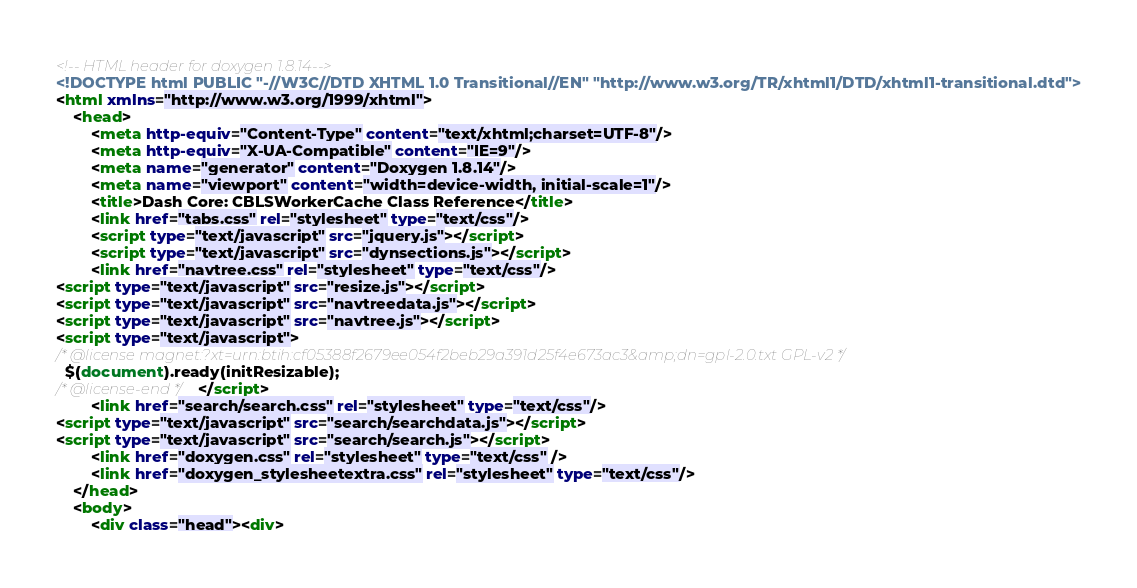<code> <loc_0><loc_0><loc_500><loc_500><_HTML_><!-- HTML header for doxygen 1.8.14-->
<!DOCTYPE html PUBLIC "-//W3C//DTD XHTML 1.0 Transitional//EN" "http://www.w3.org/TR/xhtml1/DTD/xhtml1-transitional.dtd">
<html xmlns="http://www.w3.org/1999/xhtml">
	<head>
		<meta http-equiv="Content-Type" content="text/xhtml;charset=UTF-8"/>
		<meta http-equiv="X-UA-Compatible" content="IE=9"/>
		<meta name="generator" content="Doxygen 1.8.14"/>
		<meta name="viewport" content="width=device-width, initial-scale=1"/>
		<title>Dash Core: CBLSWorkerCache Class Reference</title>
		<link href="tabs.css" rel="stylesheet" type="text/css"/>
		<script type="text/javascript" src="jquery.js"></script>
		<script type="text/javascript" src="dynsections.js"></script>
		<link href="navtree.css" rel="stylesheet" type="text/css"/>
<script type="text/javascript" src="resize.js"></script>
<script type="text/javascript" src="navtreedata.js"></script>
<script type="text/javascript" src="navtree.js"></script>
<script type="text/javascript">
/* @license magnet:?xt=urn:btih:cf05388f2679ee054f2beb29a391d25f4e673ac3&amp;dn=gpl-2.0.txt GPL-v2 */
  $(document).ready(initResizable);
/* @license-end */</script>
		<link href="search/search.css" rel="stylesheet" type="text/css"/>
<script type="text/javascript" src="search/searchdata.js"></script>
<script type="text/javascript" src="search/search.js"></script>
		<link href="doxygen.css" rel="stylesheet" type="text/css" />
		<link href="doxygen_stylesheetextra.css" rel="stylesheet" type="text/css"/>
	</head>
	<body>
		<div class="head"><div></code> 